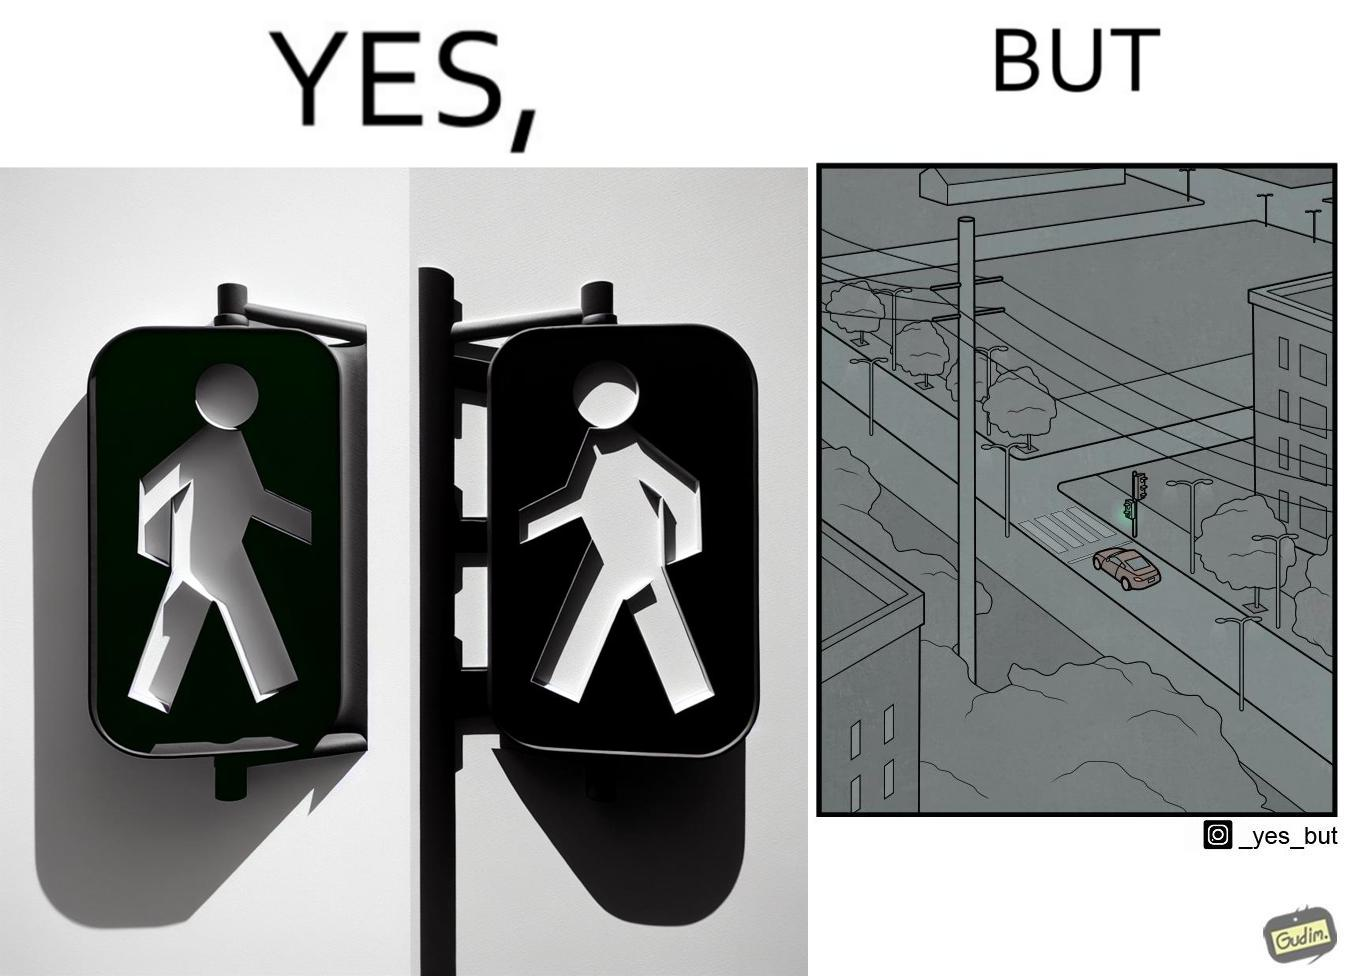Would you classify this image as satirical? Yes, this image is satirical. 